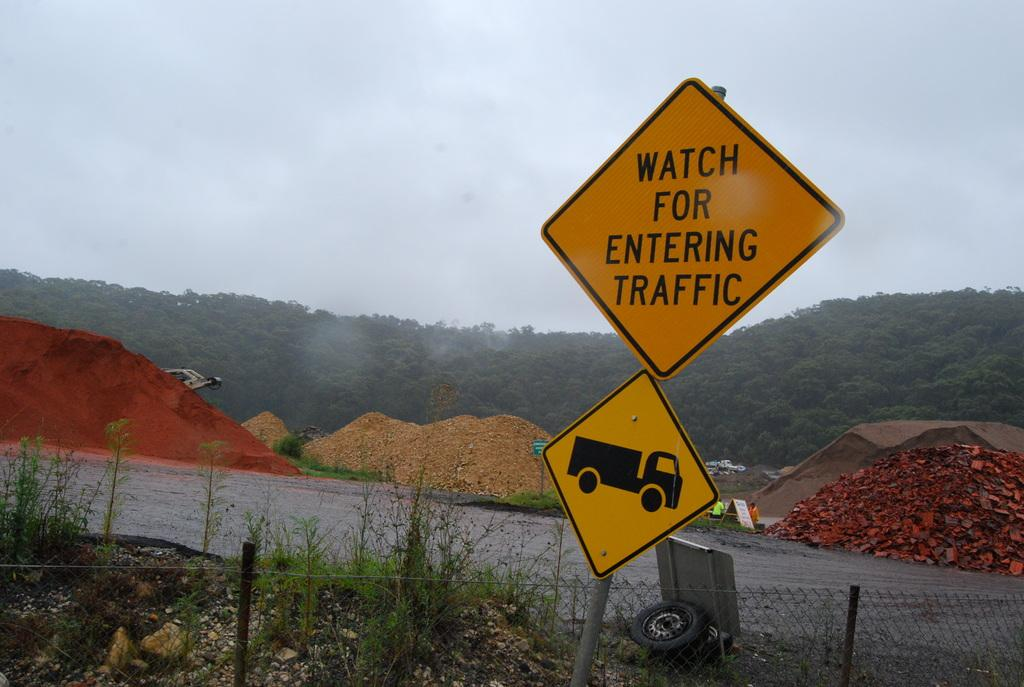<image>
Offer a succinct explanation of the picture presented. A road sign that says Watch for Entering traffic. 